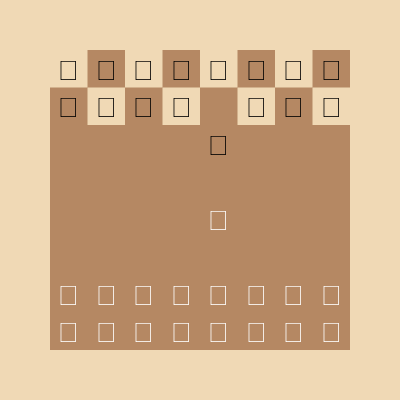Based on the chess board diagram, which popular opening is being played, and what is White's next logical move? Let's analyze the position step-by-step:

1. We can see that most pieces are in their starting positions.
2. The only moves that have been made are:
   a) White's e-pawn (King's pawn) has moved to e4 (two squares forward).
   b) Black's e-pawn has also moved to e5 (two squares forward).

3. This position is the result of the moves:
   1. e4 e5

4. This is the starting position of the "King's Pawn Opening" or "Open Game."

5. In this position, the most common and theoretically sound move for White is to develop the King's Knight to f3. This move:
   a) Develops a piece
   b) Controls the central e5 square
   c) Prepares for castling
   d) Sets up various attacking possibilities

6. The move Nf3 (Knight to f3) leads to the "King's Knight Opening," which can transpose into many popular openings like the Ruy Lopez, Italian Game, or Scotch Game.

Therefore, the logical next move for White is Nf3 (Knight to f3).
Answer: King's Pawn Opening; Nf3 